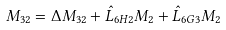<formula> <loc_0><loc_0><loc_500><loc_500>M _ { 3 2 } & = \Delta M _ { 3 2 } + \hat { L } _ { 6 H 2 } M _ { 2 } + \hat { L } _ { 6 G 3 } M _ { 2 }</formula> 